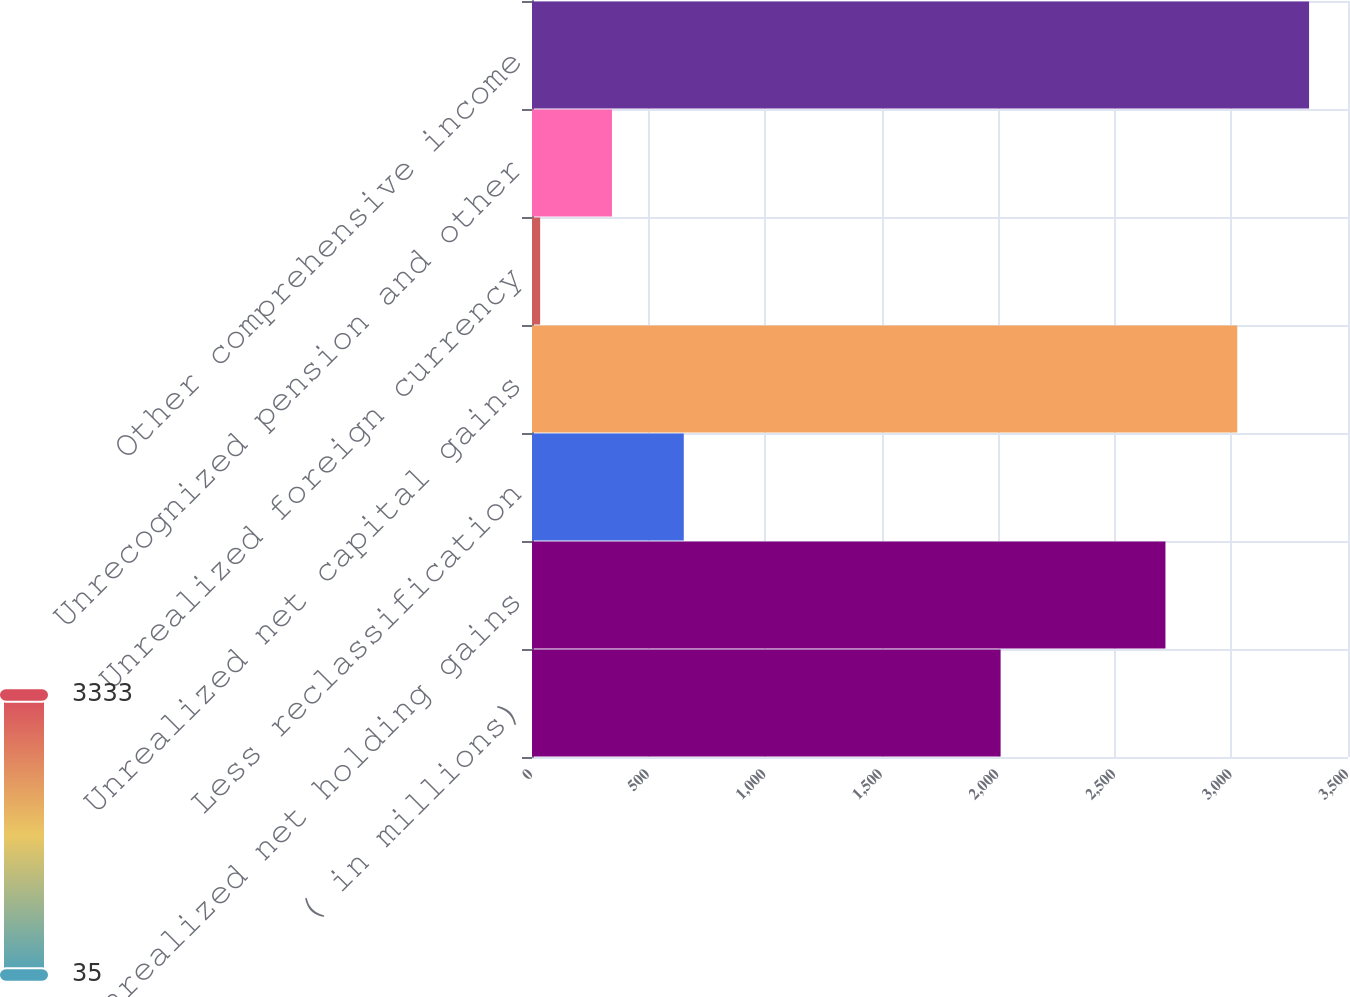<chart> <loc_0><loc_0><loc_500><loc_500><bar_chart><fcel>( in millions)<fcel>Unrealized net holding gains<fcel>Less reclassification<fcel>Unrealized net capital gains<fcel>Unrealized foreign currency<fcel>Unrecognized pension and other<fcel>Other comprehensive income<nl><fcel>2010<fcel>2717<fcel>651<fcel>3025<fcel>35<fcel>343<fcel>3333<nl></chart> 